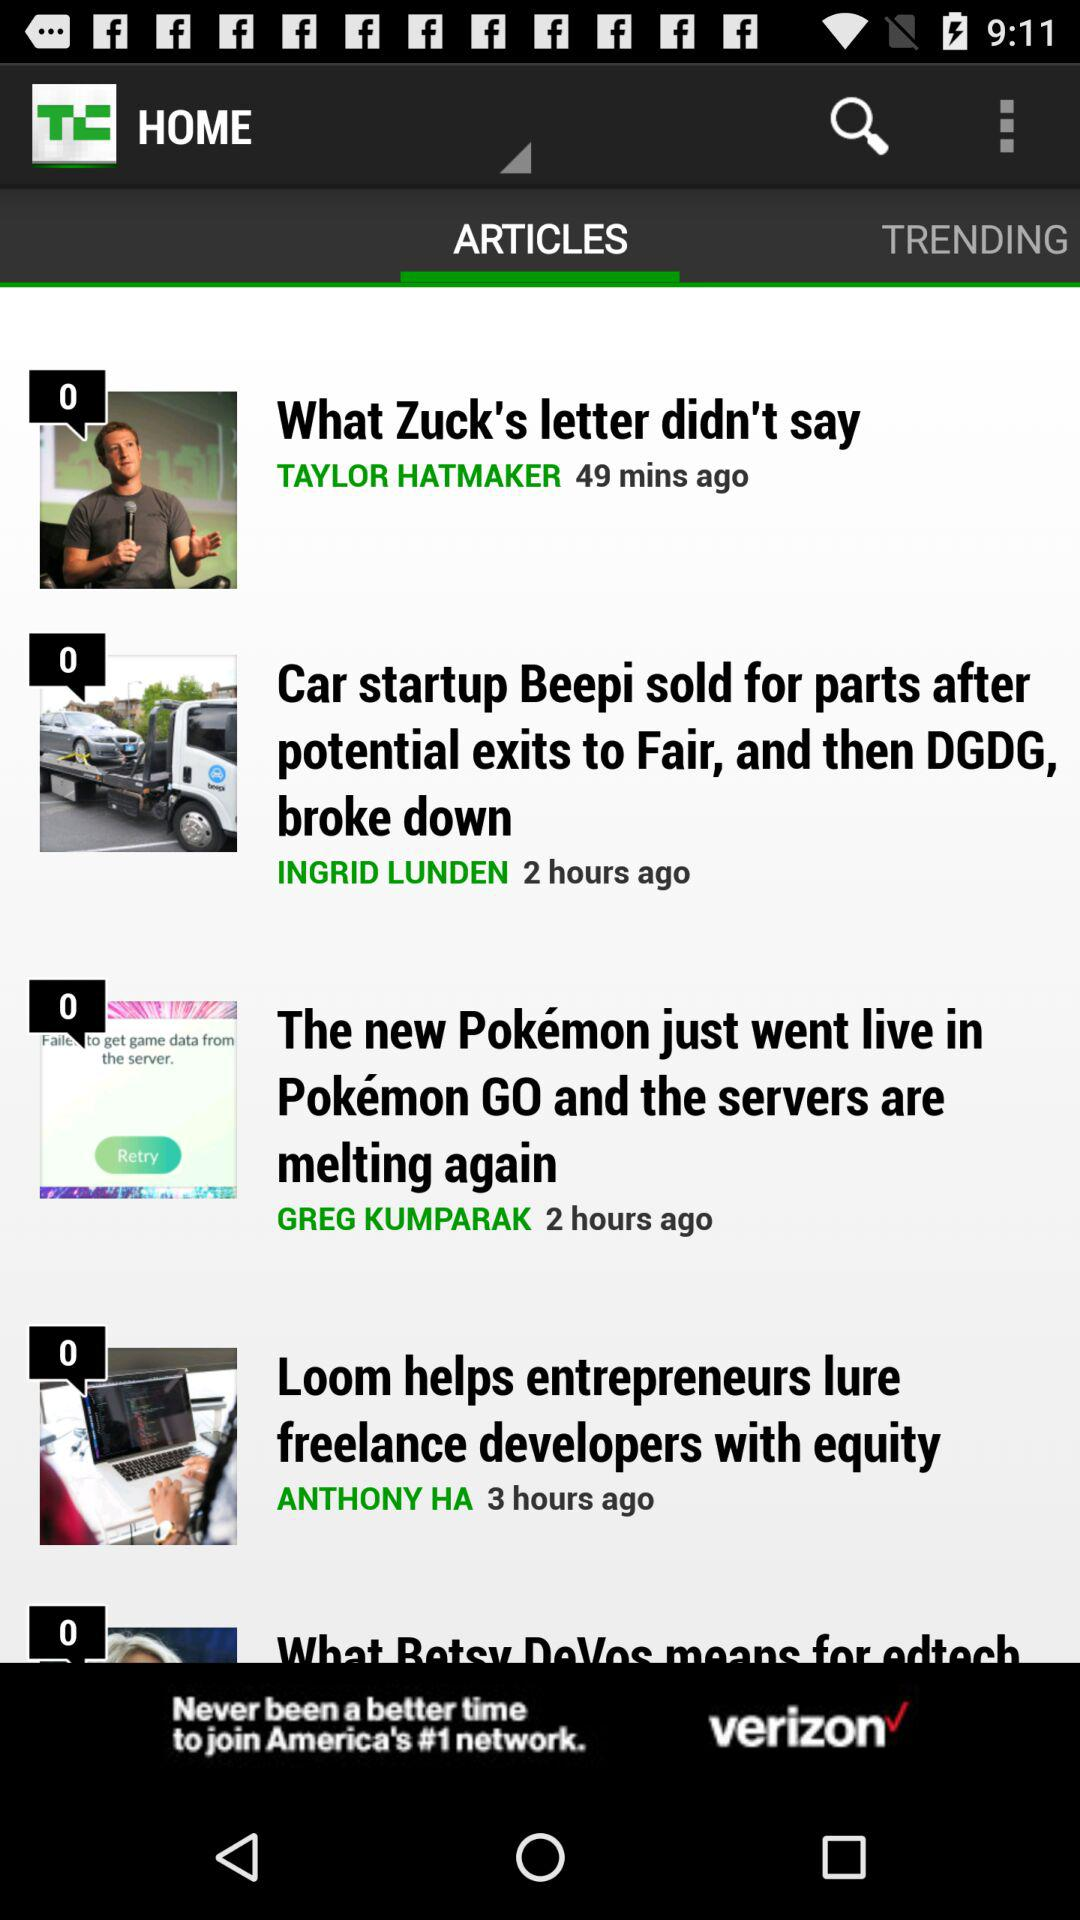Who has posted the article "Loom helps entrepreneurs lure freelance developers with equity"? The article "Loom helps entrepreneurs lure freelance developers with equity" has been posted by Anthony Ha. 